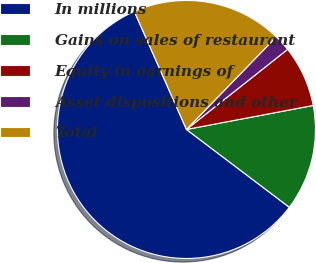Convert chart. <chart><loc_0><loc_0><loc_500><loc_500><pie_chart><fcel>In millions<fcel>Gains on sales of restaurant<fcel>Equity in earnings of<fcel>Asset dispositions and other<fcel>Total<nl><fcel>58.07%<fcel>13.28%<fcel>7.68%<fcel>2.08%<fcel>18.88%<nl></chart> 